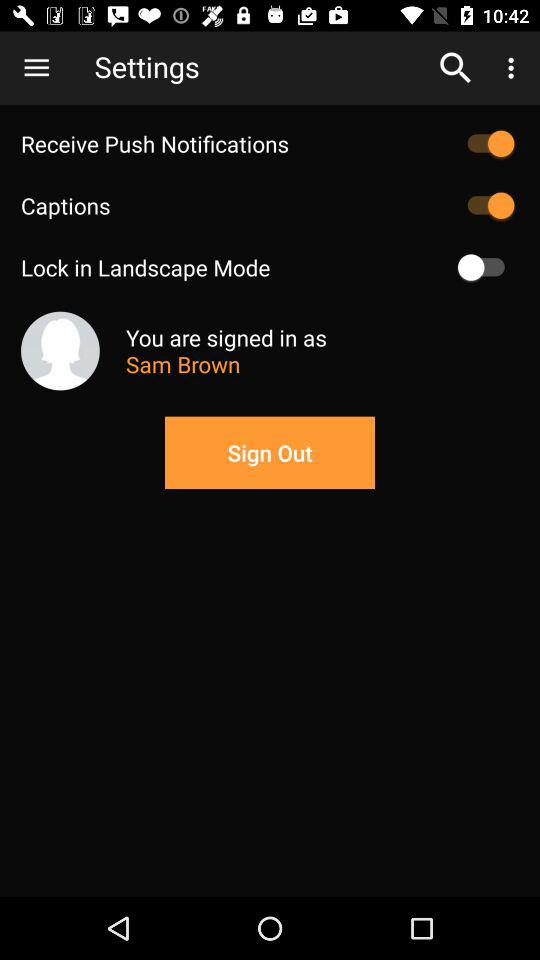What is the status of "Captions"? The status is "on". 